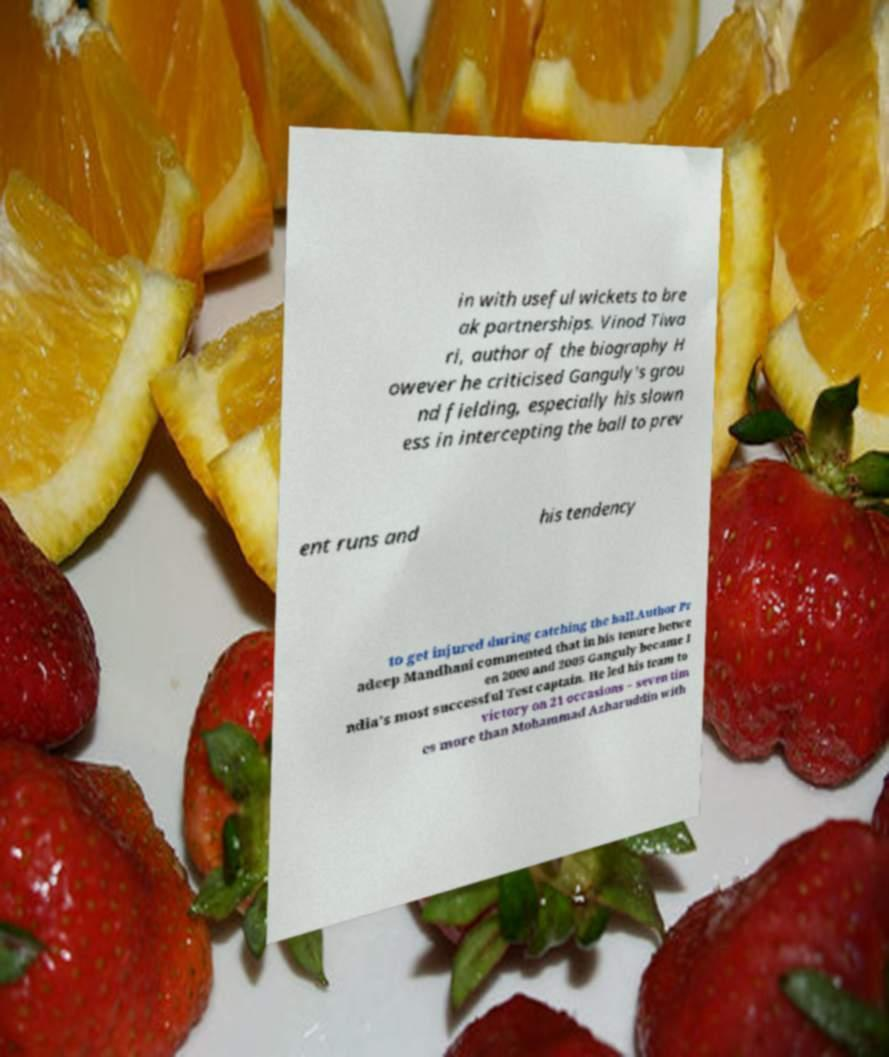Could you extract and type out the text from this image? in with useful wickets to bre ak partnerships. Vinod Tiwa ri, author of the biography H owever he criticised Ganguly's grou nd fielding, especially his slown ess in intercepting the ball to prev ent runs and his tendency to get injured during catching the ball.Author Pr adeep Mandhani commented that in his tenure betwe en 2000 and 2005 Ganguly became I ndia's most successful Test captain. He led his team to victory on 21 occasions – seven tim es more than Mohammad Azharuddin with 